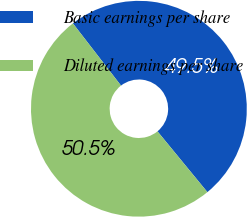Convert chart. <chart><loc_0><loc_0><loc_500><loc_500><pie_chart><fcel>Basic earnings per share<fcel>Diluted earnings per share<nl><fcel>49.53%<fcel>50.47%<nl></chart> 